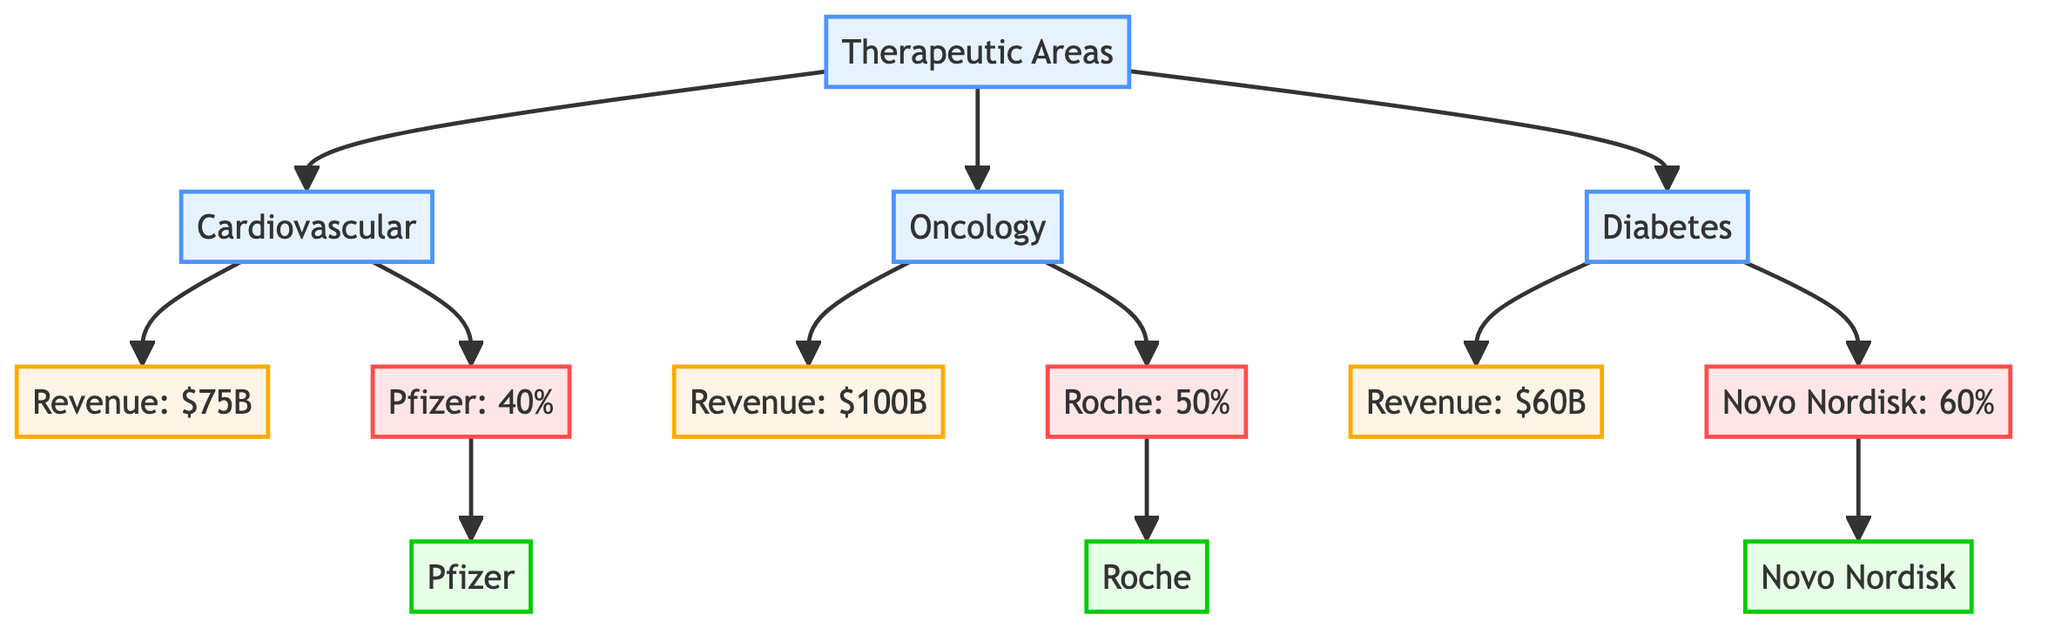What is the revenue of the Oncology sector? According to the diagram, the node for the Oncology revenue indicates a value of $100B. This can be found directly under the Oncology area in the flowchart.
Answer: $100B How much revenue is generated from the Cardiovascular category? The diagram specifies that the revenue from the Cardiovascular category is represented by the node labeled "Revenue: $75B", which connects under the Cardiovascular area.
Answer: $75B Which company has the highest market share in the Diabetes category? The diagram shows that Novo Nordisk has a market share of 60% in the Diabetes category, which is higher than any other company's share in a single category.
Answer: Novo Nordisk What percentage of the Cardiovascular market does Pfizer control? From the diagram, Pfizer's market share in the Cardiovascular category is displayed as "Pfizer: 40%", which directly indicates their share in this specific therapeutic area.
Answer: 40% Which company has the largest overall revenue share among the listed companies? The Oncology revenue of $100B is attributed to Roche, while Cardiovascular and Diabetes revenues are $75B (Pfizer) and $60B (Novo Nordisk) respectively. Since Roche's revenue in Oncology is the highest, they hold the largest overall revenue share.
Answer: Roche How many therapeutic areas are represented in the diagram? The diagram outlines three therapeutic areas: Cardiovascular, Oncology, and Diabetes. This can be seen in the initial branching from the "Therapeutic Areas" node.
Answer: 3 What is the combined revenue from Cardiovascular and Diabetes categories? To find the combined revenue, the revenues from Cardiovascular ($75B) and Diabetes ($60B) must be summed: $75B + $60B = $135B. The respective revenues can be referenced from their specific nodes.
Answer: $135B Which therapeutic area has the lowest revenue? The diagram indicates that the Diabetes revenue at $60B is less than the Cardiovascular revenue ($75B) and Oncology revenue ($100B), making it the area with the lowest revenue.
Answer: Diabetes 